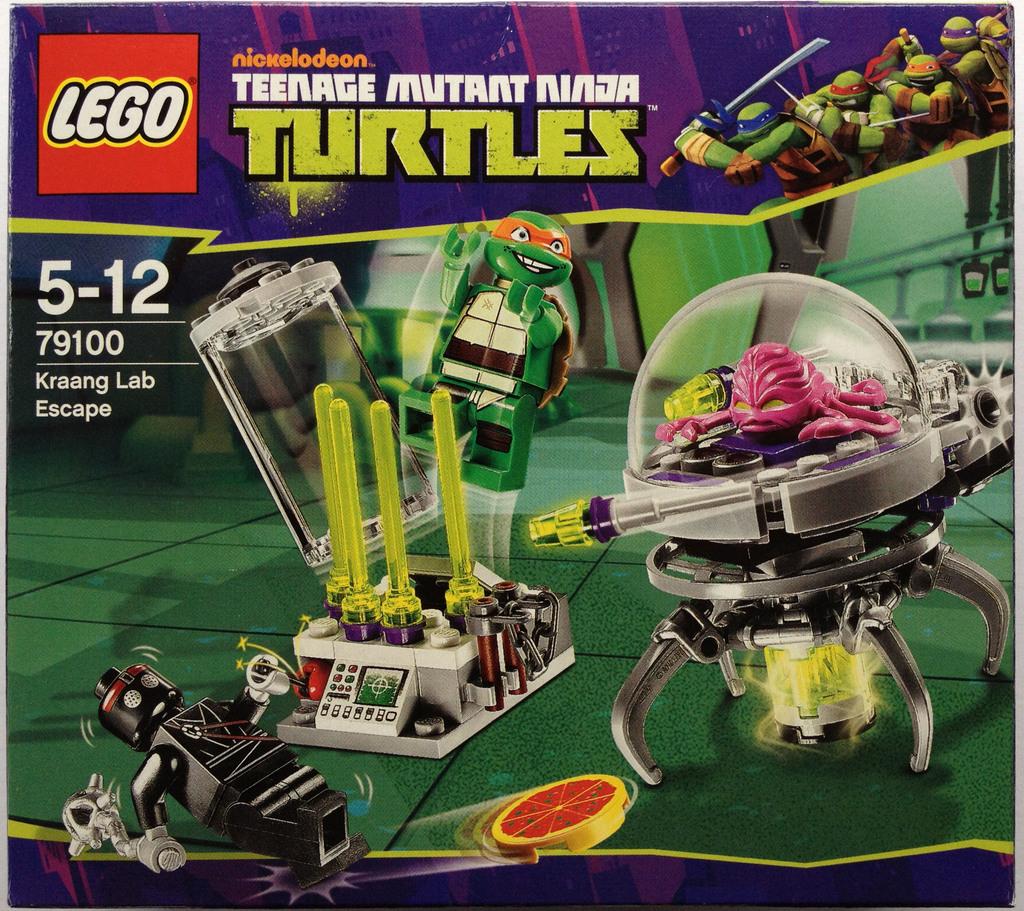What kind of turtles?
Give a very brief answer. Teenage mutant ninja. What color is the ninja turtle?
Make the answer very short. Answering does not require reading text in the image. 